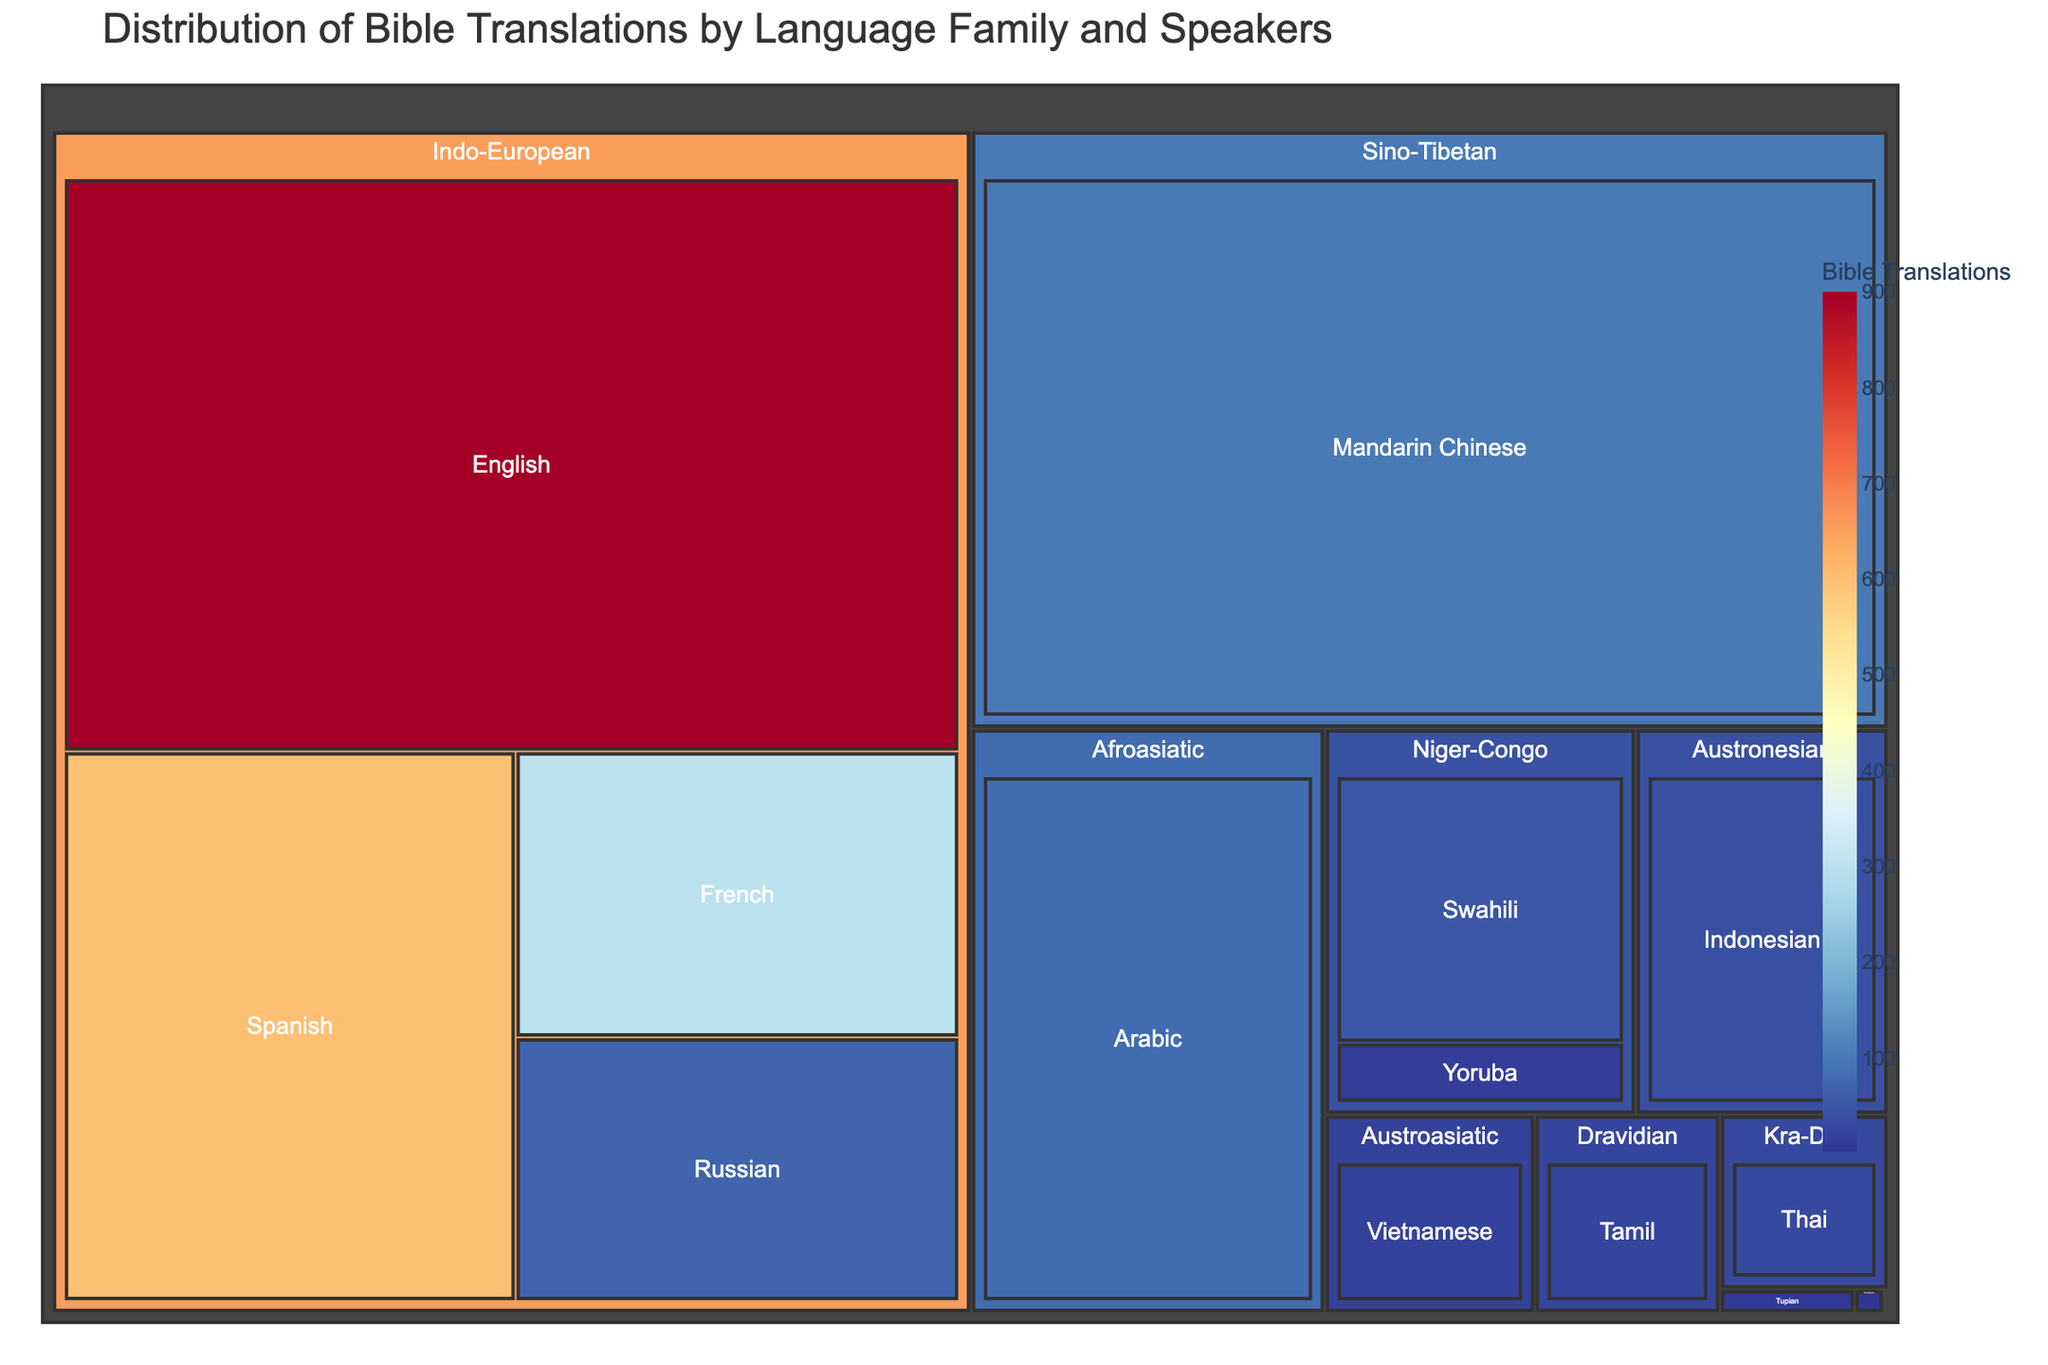Which language family has the most Bible translations? To find out which language family has the most Bible translations, observe the color coding in the treemap. The Indo-European family will have the highest value as it encompasses multiple languages with higher Bible translations count.
Answer: Indo-European What is the number of speakers for the language with the highest number of Bible translations? Look for the language with the darkest shade of color, which represents the highest number of Bible translations. English has 900 translations. The corresponding number of speakers of English is shown to be 1,132,000,000.
Answer: 1,132,000,000 How many languages have fewer than 10 Bible translations? Count the languages with Bible translations under 10 based on their color shade and respective hover information. Enga, Guarani, and Dinka fit this criterion.
Answer: 3 Which language has the second highest number of Bible translations? Identify the languages with the two darkest shades. English has the highest, then refer to Spanish, which has the second highest, shown to have 600 translations.
Answer: Spanish Which language family has the second fewest speakers and how many speakers are there? Sum the total number of speakers for each language family. The totals are: 
  - Indo-European: 1982M
  - Niger-Congo: 245M
  - Sino-Tibetan: 1120M
  - Afroasiatic: 422M
  - Austronesian: 199M
  - Austroasiatic: 85M
  - Dravidian: 75M
  - Tupian: 6.5M
  - Nilo-Saharan: 1.4M
  - Kra-Dai: 60M
  
Trans-New Guinea, at 0.23M, and Tupian, at 6.5M, have the fewest. Thus the second fewest is Tupian.
Answer: 6.5M Which language family contains the language with the fewest Bible translations? Find the language with the lightest color, representing the fewest translations. Dinka has the fewest at 3. It belongs to the Nilo-Saharan family.
Answer: Nilo-Saharan Which language has the greatest disparity between the number of speakers and the number of Bible translations? Look for the language with a large difference between speakers count and translations. Generally, English with 1,132M speakers and 900 translations shows a large discrepancy.
Answer: English 